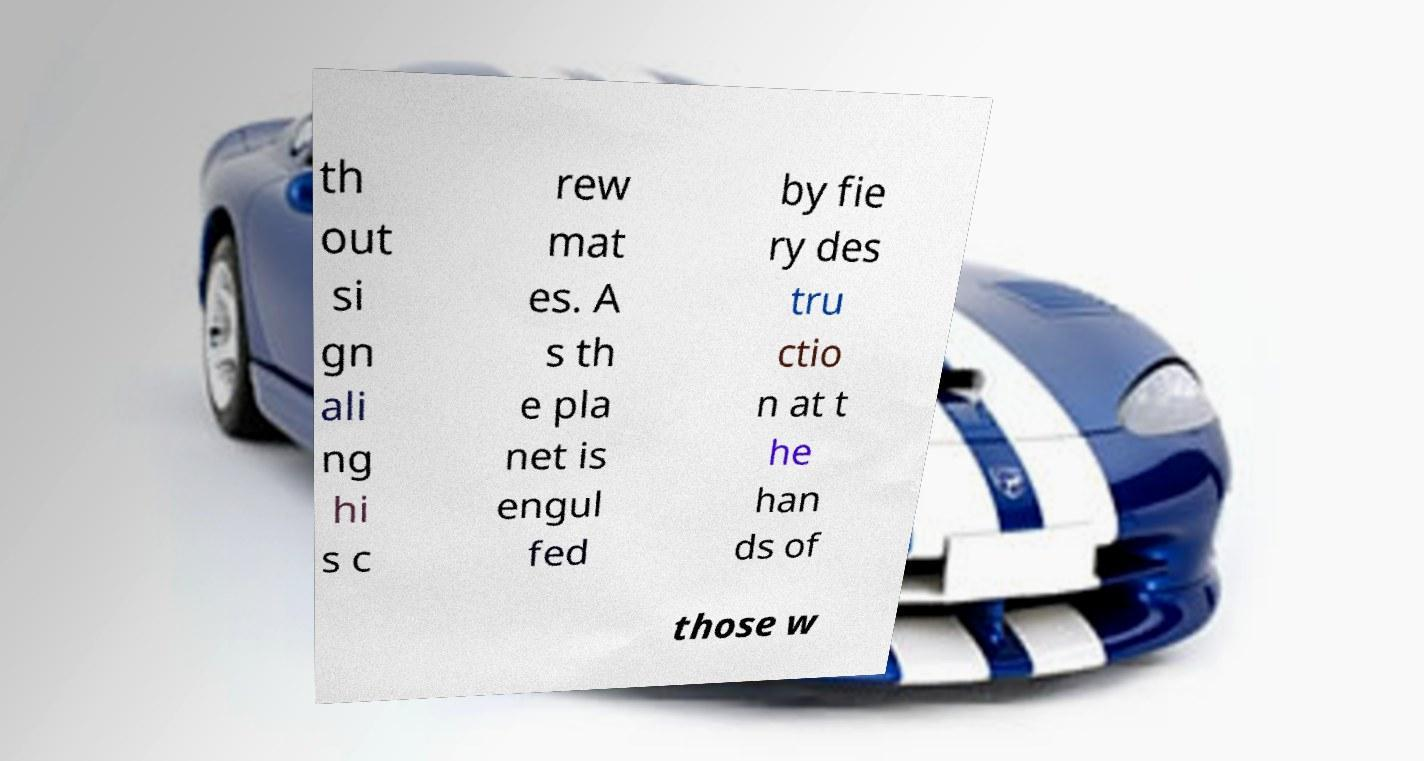Please identify and transcribe the text found in this image. th out si gn ali ng hi s c rew mat es. A s th e pla net is engul fed by fie ry des tru ctio n at t he han ds of those w 